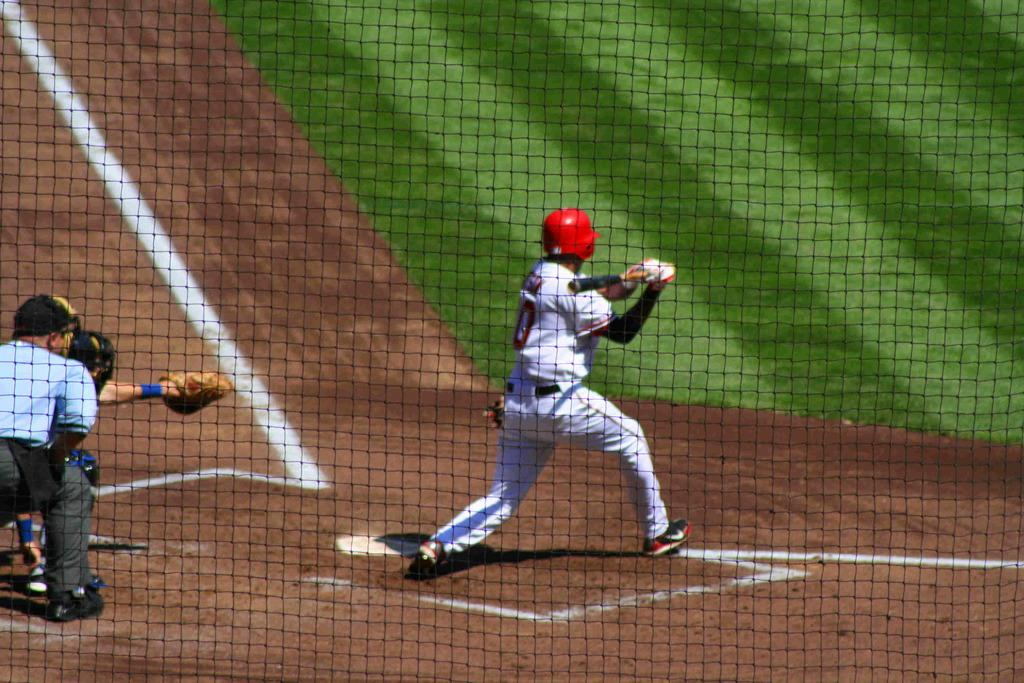What is the man in the image holding? The man is holding a bat in the image. How many people are present in the image? There are two people standing in the image. What type of terrain is visible in the image? There is mud and grass in the image. What type of pen can be seen in the image? There is no pen present in the image. How does the air support the people in the image? The air does not support the people in the image; they are standing on the ground. 